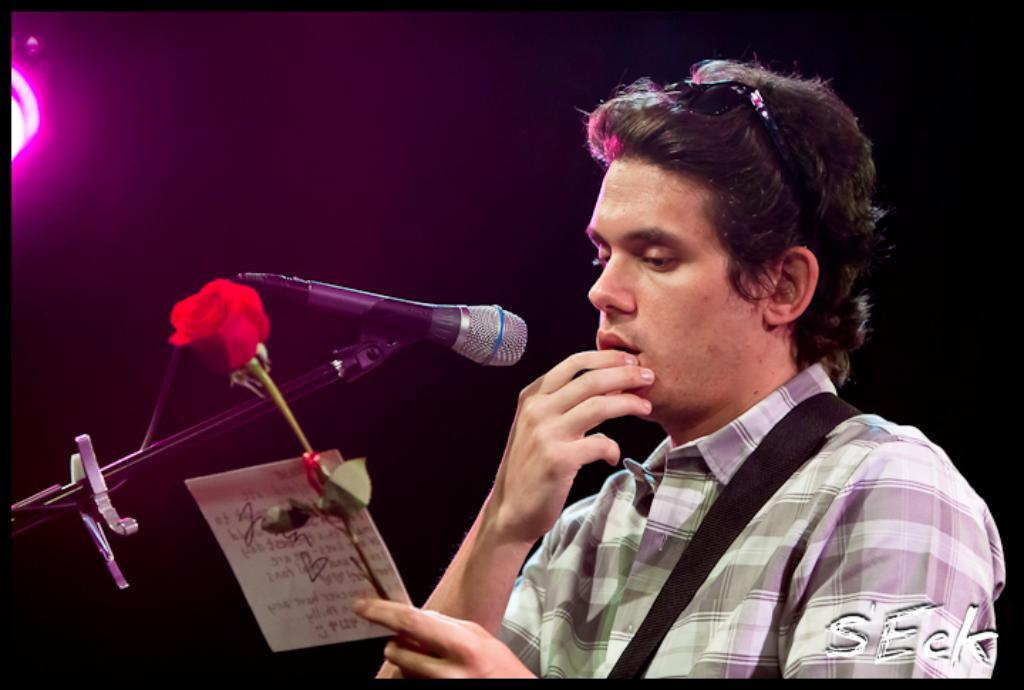Who is the main subject in the image? There is a man in the image. What is the man holding in the image? The man is holding a flower and a card. What is the man standing in front of in the image? The man is standing in front of a microphone. What can be seen in the background of the image? There is a light and both light and dark colors in the background of the image. How is the image displayed? The image appears to be in a photo frame. What type of lunch is the man eating in the image? There is no lunch present in the image; the man is holding a flower and a card. 